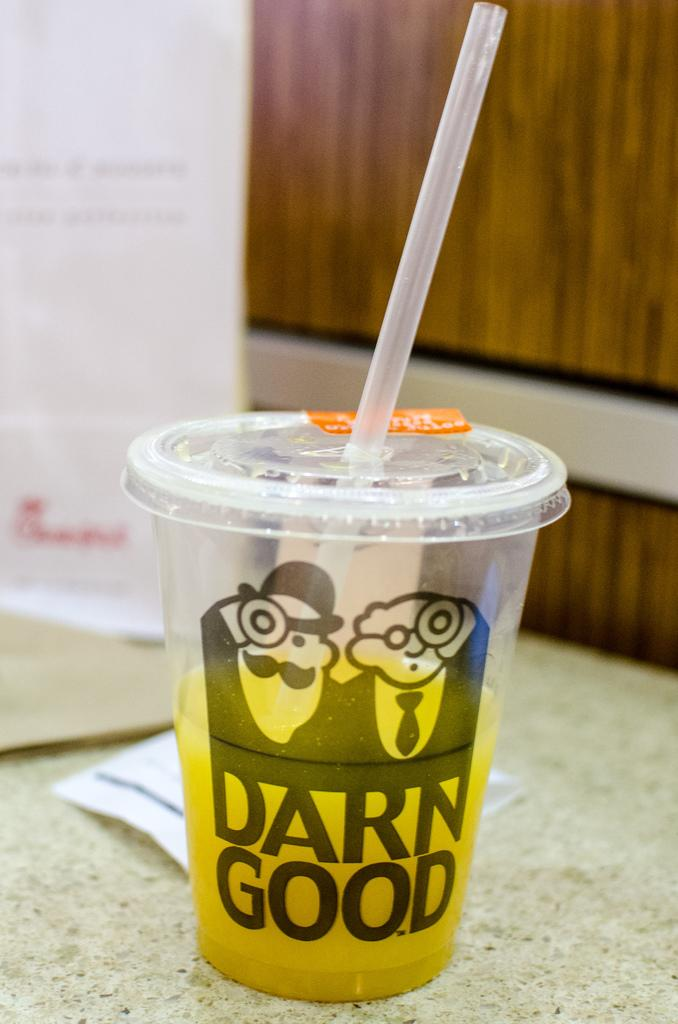What is in the glass that is visible in the image? There is a glass with a soft drink in the image. What type of drink is in the glass? The drink is a soft drink. How can the soft drink be consumed from the glass? There is a straw in the glass. What can be seen in the background of the image? There is a wall in the background of the image. What is attached to the wall in the image? There is a wooden plank on the wall. What is the weight of the representative in the image? There is no representative present in the image, so it is not possible to determine their weight. 